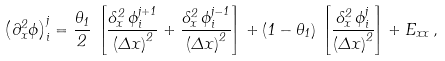<formula> <loc_0><loc_0><loc_500><loc_500>\left ( \partial ^ { 2 } _ { x } \phi \right ) ^ { j } _ { i } = \frac { \theta _ { 1 } } { 2 } \, \left [ \frac { \delta ^ { 2 } _ { x } \, \phi ^ { j + 1 } _ { i } } { \left ( \Delta x \right ) ^ { 2 } } + \frac { \delta ^ { 2 } _ { x } \, \phi ^ { j - 1 } _ { i } } { \left ( \Delta x \right ) ^ { 2 } } \right ] + \left ( 1 - \theta _ { 1 } \right ) \, \left [ \frac { \delta ^ { 2 } _ { x } \, \phi ^ { j } _ { i } } { \left ( \Delta x \right ) ^ { 2 } } \right ] + E _ { x x } \, ,</formula> 